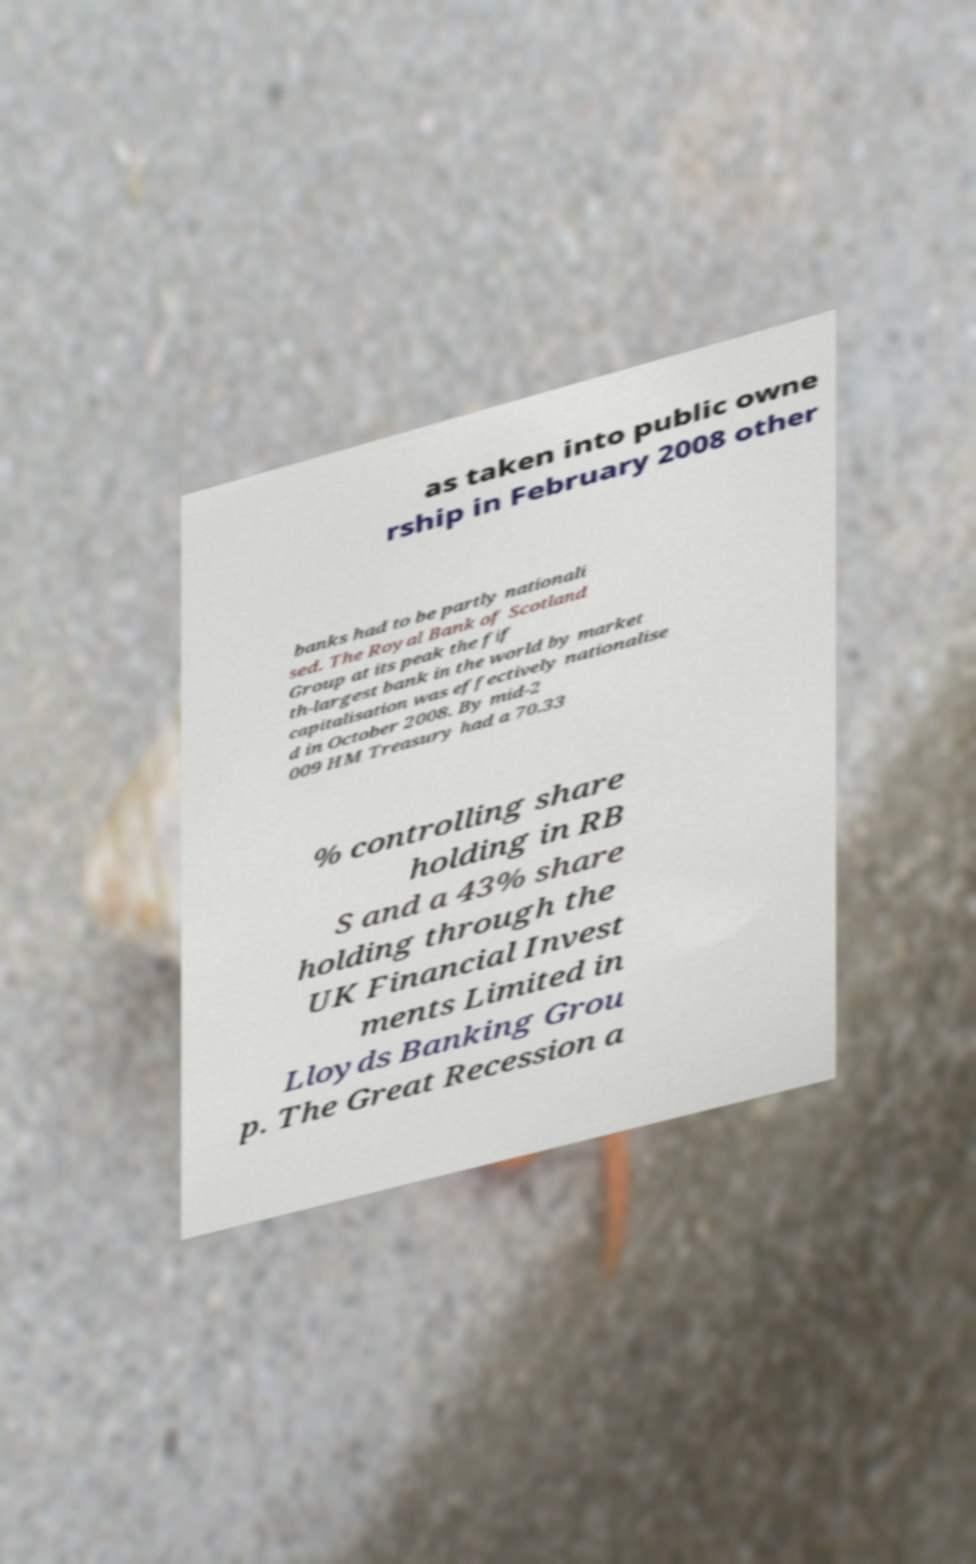There's text embedded in this image that I need extracted. Can you transcribe it verbatim? as taken into public owne rship in February 2008 other banks had to be partly nationali sed. The Royal Bank of Scotland Group at its peak the fif th-largest bank in the world by market capitalisation was effectively nationalise d in October 2008. By mid-2 009 HM Treasury had a 70.33 % controlling share holding in RB S and a 43% share holding through the UK Financial Invest ments Limited in Lloyds Banking Grou p. The Great Recession a 